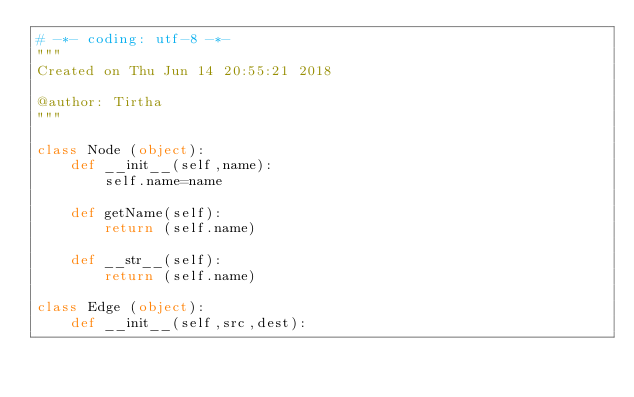Convert code to text. <code><loc_0><loc_0><loc_500><loc_500><_Python_># -*- coding: utf-8 -*-
"""
Created on Thu Jun 14 20:55:21 2018

@author: Tirtha
"""

class Node (object):
    def __init__(self,name):
        self.name=name
        
    def getName(self):
        return (self.name)
    
    def __str__(self):
        return (self.name)

class Edge (object):
    def __init__(self,src,dest):</code> 